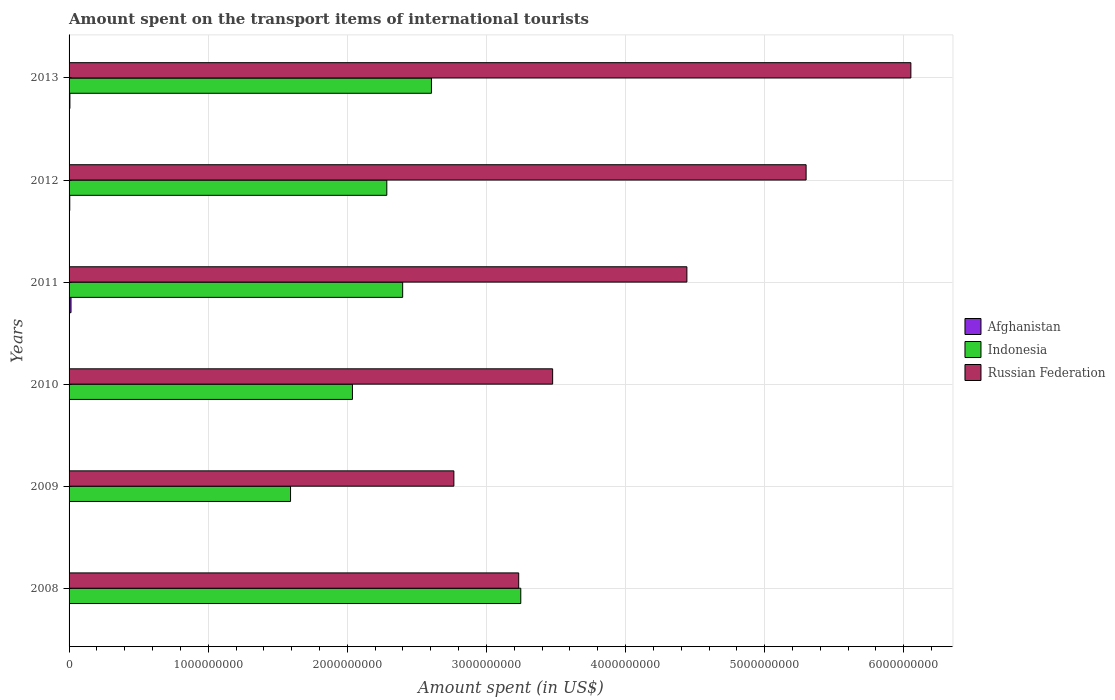How many different coloured bars are there?
Ensure brevity in your answer.  3. Are the number of bars per tick equal to the number of legend labels?
Give a very brief answer. Yes. Are the number of bars on each tick of the Y-axis equal?
Ensure brevity in your answer.  Yes. What is the label of the 6th group of bars from the top?
Your answer should be very brief. 2008. What is the amount spent on the transport items of international tourists in Russian Federation in 2013?
Provide a short and direct response. 6.05e+09. Across all years, what is the maximum amount spent on the transport items of international tourists in Russian Federation?
Provide a short and direct response. 6.05e+09. Across all years, what is the minimum amount spent on the transport items of international tourists in Indonesia?
Provide a succinct answer. 1.59e+09. In which year was the amount spent on the transport items of international tourists in Afghanistan minimum?
Make the answer very short. 2009. What is the total amount spent on the transport items of international tourists in Afghanistan in the graph?
Your response must be concise. 3.30e+07. What is the difference between the amount spent on the transport items of international tourists in Afghanistan in 2011 and that in 2013?
Your answer should be compact. 8.00e+06. What is the difference between the amount spent on the transport items of international tourists in Indonesia in 2010 and the amount spent on the transport items of international tourists in Russian Federation in 2011?
Offer a very short reply. -2.40e+09. What is the average amount spent on the transport items of international tourists in Afghanistan per year?
Give a very brief answer. 5.50e+06. In the year 2008, what is the difference between the amount spent on the transport items of international tourists in Indonesia and amount spent on the transport items of international tourists in Russian Federation?
Your answer should be very brief. 1.50e+07. In how many years, is the amount spent on the transport items of international tourists in Indonesia greater than 4600000000 US$?
Your response must be concise. 0. What is the ratio of the amount spent on the transport items of international tourists in Russian Federation in 2009 to that in 2013?
Your answer should be compact. 0.46. Is the amount spent on the transport items of international tourists in Afghanistan in 2009 less than that in 2010?
Provide a short and direct response. Yes. What is the difference between the highest and the second highest amount spent on the transport items of international tourists in Indonesia?
Make the answer very short. 6.42e+08. What is the difference between the highest and the lowest amount spent on the transport items of international tourists in Russian Federation?
Your answer should be very brief. 3.28e+09. Is the sum of the amount spent on the transport items of international tourists in Afghanistan in 2008 and 2011 greater than the maximum amount spent on the transport items of international tourists in Indonesia across all years?
Provide a short and direct response. No. Is it the case that in every year, the sum of the amount spent on the transport items of international tourists in Russian Federation and amount spent on the transport items of international tourists in Indonesia is greater than the amount spent on the transport items of international tourists in Afghanistan?
Make the answer very short. Yes. How many bars are there?
Ensure brevity in your answer.  18. Are all the bars in the graph horizontal?
Make the answer very short. Yes. Are the values on the major ticks of X-axis written in scientific E-notation?
Make the answer very short. No. Does the graph contain any zero values?
Offer a very short reply. No. How are the legend labels stacked?
Offer a terse response. Vertical. What is the title of the graph?
Provide a short and direct response. Amount spent on the transport items of international tourists. Does "Namibia" appear as one of the legend labels in the graph?
Offer a terse response. No. What is the label or title of the X-axis?
Offer a terse response. Amount spent (in US$). What is the label or title of the Y-axis?
Provide a succinct answer. Years. What is the Amount spent (in US$) of Afghanistan in 2008?
Keep it short and to the point. 3.00e+06. What is the Amount spent (in US$) of Indonesia in 2008?
Keep it short and to the point. 3.25e+09. What is the Amount spent (in US$) of Russian Federation in 2008?
Provide a short and direct response. 3.23e+09. What is the Amount spent (in US$) in Indonesia in 2009?
Provide a short and direct response. 1.59e+09. What is the Amount spent (in US$) in Russian Federation in 2009?
Your answer should be very brief. 2.77e+09. What is the Amount spent (in US$) in Afghanistan in 2010?
Your answer should be very brief. 3.00e+06. What is the Amount spent (in US$) in Indonesia in 2010?
Your response must be concise. 2.04e+09. What is the Amount spent (in US$) in Russian Federation in 2010?
Ensure brevity in your answer.  3.48e+09. What is the Amount spent (in US$) in Afghanistan in 2011?
Your answer should be very brief. 1.40e+07. What is the Amount spent (in US$) in Indonesia in 2011?
Keep it short and to the point. 2.40e+09. What is the Amount spent (in US$) in Russian Federation in 2011?
Offer a terse response. 4.44e+09. What is the Amount spent (in US$) of Indonesia in 2012?
Give a very brief answer. 2.28e+09. What is the Amount spent (in US$) in Russian Federation in 2012?
Ensure brevity in your answer.  5.30e+09. What is the Amount spent (in US$) in Indonesia in 2013?
Provide a succinct answer. 2.60e+09. What is the Amount spent (in US$) of Russian Federation in 2013?
Give a very brief answer. 6.05e+09. Across all years, what is the maximum Amount spent (in US$) in Afghanistan?
Make the answer very short. 1.40e+07. Across all years, what is the maximum Amount spent (in US$) in Indonesia?
Offer a terse response. 3.25e+09. Across all years, what is the maximum Amount spent (in US$) in Russian Federation?
Offer a very short reply. 6.05e+09. Across all years, what is the minimum Amount spent (in US$) in Indonesia?
Your response must be concise. 1.59e+09. Across all years, what is the minimum Amount spent (in US$) of Russian Federation?
Ensure brevity in your answer.  2.77e+09. What is the total Amount spent (in US$) of Afghanistan in the graph?
Ensure brevity in your answer.  3.30e+07. What is the total Amount spent (in US$) in Indonesia in the graph?
Provide a succinct answer. 1.42e+1. What is the total Amount spent (in US$) in Russian Federation in the graph?
Ensure brevity in your answer.  2.53e+1. What is the difference between the Amount spent (in US$) of Indonesia in 2008 and that in 2009?
Provide a succinct answer. 1.66e+09. What is the difference between the Amount spent (in US$) of Russian Federation in 2008 and that in 2009?
Keep it short and to the point. 4.66e+08. What is the difference between the Amount spent (in US$) of Indonesia in 2008 and that in 2010?
Your answer should be very brief. 1.21e+09. What is the difference between the Amount spent (in US$) in Russian Federation in 2008 and that in 2010?
Offer a terse response. -2.44e+08. What is the difference between the Amount spent (in US$) of Afghanistan in 2008 and that in 2011?
Provide a succinct answer. -1.10e+07. What is the difference between the Amount spent (in US$) in Indonesia in 2008 and that in 2011?
Offer a very short reply. 8.49e+08. What is the difference between the Amount spent (in US$) of Russian Federation in 2008 and that in 2011?
Provide a short and direct response. -1.21e+09. What is the difference between the Amount spent (in US$) in Indonesia in 2008 and that in 2012?
Offer a terse response. 9.63e+08. What is the difference between the Amount spent (in US$) in Russian Federation in 2008 and that in 2012?
Your answer should be compact. -2.07e+09. What is the difference between the Amount spent (in US$) of Indonesia in 2008 and that in 2013?
Provide a succinct answer. 6.42e+08. What is the difference between the Amount spent (in US$) of Russian Federation in 2008 and that in 2013?
Your response must be concise. -2.82e+09. What is the difference between the Amount spent (in US$) of Indonesia in 2009 and that in 2010?
Make the answer very short. -4.45e+08. What is the difference between the Amount spent (in US$) in Russian Federation in 2009 and that in 2010?
Your answer should be very brief. -7.10e+08. What is the difference between the Amount spent (in US$) of Afghanistan in 2009 and that in 2011?
Give a very brief answer. -1.20e+07. What is the difference between the Amount spent (in US$) of Indonesia in 2009 and that in 2011?
Provide a short and direct response. -8.06e+08. What is the difference between the Amount spent (in US$) in Russian Federation in 2009 and that in 2011?
Provide a succinct answer. -1.68e+09. What is the difference between the Amount spent (in US$) of Indonesia in 2009 and that in 2012?
Your answer should be compact. -6.92e+08. What is the difference between the Amount spent (in US$) of Russian Federation in 2009 and that in 2012?
Ensure brevity in your answer.  -2.53e+09. What is the difference between the Amount spent (in US$) in Afghanistan in 2009 and that in 2013?
Your answer should be very brief. -4.00e+06. What is the difference between the Amount spent (in US$) in Indonesia in 2009 and that in 2013?
Your answer should be very brief. -1.01e+09. What is the difference between the Amount spent (in US$) of Russian Federation in 2009 and that in 2013?
Ensure brevity in your answer.  -3.28e+09. What is the difference between the Amount spent (in US$) in Afghanistan in 2010 and that in 2011?
Keep it short and to the point. -1.10e+07. What is the difference between the Amount spent (in US$) in Indonesia in 2010 and that in 2011?
Provide a succinct answer. -3.61e+08. What is the difference between the Amount spent (in US$) of Russian Federation in 2010 and that in 2011?
Your response must be concise. -9.65e+08. What is the difference between the Amount spent (in US$) of Afghanistan in 2010 and that in 2012?
Provide a succinct answer. -2.00e+06. What is the difference between the Amount spent (in US$) in Indonesia in 2010 and that in 2012?
Keep it short and to the point. -2.47e+08. What is the difference between the Amount spent (in US$) in Russian Federation in 2010 and that in 2012?
Give a very brief answer. -1.82e+09. What is the difference between the Amount spent (in US$) of Afghanistan in 2010 and that in 2013?
Make the answer very short. -3.00e+06. What is the difference between the Amount spent (in US$) in Indonesia in 2010 and that in 2013?
Offer a terse response. -5.68e+08. What is the difference between the Amount spent (in US$) of Russian Federation in 2010 and that in 2013?
Make the answer very short. -2.58e+09. What is the difference between the Amount spent (in US$) in Afghanistan in 2011 and that in 2012?
Keep it short and to the point. 9.00e+06. What is the difference between the Amount spent (in US$) of Indonesia in 2011 and that in 2012?
Give a very brief answer. 1.14e+08. What is the difference between the Amount spent (in US$) in Russian Federation in 2011 and that in 2012?
Provide a short and direct response. -8.57e+08. What is the difference between the Amount spent (in US$) of Indonesia in 2011 and that in 2013?
Provide a succinct answer. -2.07e+08. What is the difference between the Amount spent (in US$) in Russian Federation in 2011 and that in 2013?
Provide a succinct answer. -1.61e+09. What is the difference between the Amount spent (in US$) of Indonesia in 2012 and that in 2013?
Give a very brief answer. -3.21e+08. What is the difference between the Amount spent (in US$) in Russian Federation in 2012 and that in 2013?
Provide a succinct answer. -7.53e+08. What is the difference between the Amount spent (in US$) of Afghanistan in 2008 and the Amount spent (in US$) of Indonesia in 2009?
Your response must be concise. -1.59e+09. What is the difference between the Amount spent (in US$) of Afghanistan in 2008 and the Amount spent (in US$) of Russian Federation in 2009?
Provide a short and direct response. -2.76e+09. What is the difference between the Amount spent (in US$) in Indonesia in 2008 and the Amount spent (in US$) in Russian Federation in 2009?
Offer a very short reply. 4.81e+08. What is the difference between the Amount spent (in US$) in Afghanistan in 2008 and the Amount spent (in US$) in Indonesia in 2010?
Make the answer very short. -2.03e+09. What is the difference between the Amount spent (in US$) of Afghanistan in 2008 and the Amount spent (in US$) of Russian Federation in 2010?
Keep it short and to the point. -3.47e+09. What is the difference between the Amount spent (in US$) in Indonesia in 2008 and the Amount spent (in US$) in Russian Federation in 2010?
Provide a succinct answer. -2.29e+08. What is the difference between the Amount spent (in US$) in Afghanistan in 2008 and the Amount spent (in US$) in Indonesia in 2011?
Offer a very short reply. -2.40e+09. What is the difference between the Amount spent (in US$) of Afghanistan in 2008 and the Amount spent (in US$) of Russian Federation in 2011?
Provide a short and direct response. -4.44e+09. What is the difference between the Amount spent (in US$) in Indonesia in 2008 and the Amount spent (in US$) in Russian Federation in 2011?
Make the answer very short. -1.19e+09. What is the difference between the Amount spent (in US$) in Afghanistan in 2008 and the Amount spent (in US$) in Indonesia in 2012?
Provide a short and direct response. -2.28e+09. What is the difference between the Amount spent (in US$) of Afghanistan in 2008 and the Amount spent (in US$) of Russian Federation in 2012?
Give a very brief answer. -5.30e+09. What is the difference between the Amount spent (in US$) of Indonesia in 2008 and the Amount spent (in US$) of Russian Federation in 2012?
Give a very brief answer. -2.05e+09. What is the difference between the Amount spent (in US$) in Afghanistan in 2008 and the Amount spent (in US$) in Indonesia in 2013?
Your answer should be very brief. -2.60e+09. What is the difference between the Amount spent (in US$) of Afghanistan in 2008 and the Amount spent (in US$) of Russian Federation in 2013?
Ensure brevity in your answer.  -6.05e+09. What is the difference between the Amount spent (in US$) of Indonesia in 2008 and the Amount spent (in US$) of Russian Federation in 2013?
Keep it short and to the point. -2.80e+09. What is the difference between the Amount spent (in US$) of Afghanistan in 2009 and the Amount spent (in US$) of Indonesia in 2010?
Offer a very short reply. -2.04e+09. What is the difference between the Amount spent (in US$) in Afghanistan in 2009 and the Amount spent (in US$) in Russian Federation in 2010?
Provide a short and direct response. -3.47e+09. What is the difference between the Amount spent (in US$) of Indonesia in 2009 and the Amount spent (in US$) of Russian Federation in 2010?
Make the answer very short. -1.88e+09. What is the difference between the Amount spent (in US$) of Afghanistan in 2009 and the Amount spent (in US$) of Indonesia in 2011?
Your answer should be very brief. -2.40e+09. What is the difference between the Amount spent (in US$) in Afghanistan in 2009 and the Amount spent (in US$) in Russian Federation in 2011?
Your answer should be very brief. -4.44e+09. What is the difference between the Amount spent (in US$) of Indonesia in 2009 and the Amount spent (in US$) of Russian Federation in 2011?
Give a very brief answer. -2.85e+09. What is the difference between the Amount spent (in US$) in Afghanistan in 2009 and the Amount spent (in US$) in Indonesia in 2012?
Make the answer very short. -2.28e+09. What is the difference between the Amount spent (in US$) in Afghanistan in 2009 and the Amount spent (in US$) in Russian Federation in 2012?
Keep it short and to the point. -5.30e+09. What is the difference between the Amount spent (in US$) in Indonesia in 2009 and the Amount spent (in US$) in Russian Federation in 2012?
Keep it short and to the point. -3.71e+09. What is the difference between the Amount spent (in US$) of Afghanistan in 2009 and the Amount spent (in US$) of Indonesia in 2013?
Keep it short and to the point. -2.60e+09. What is the difference between the Amount spent (in US$) of Afghanistan in 2009 and the Amount spent (in US$) of Russian Federation in 2013?
Give a very brief answer. -6.05e+09. What is the difference between the Amount spent (in US$) of Indonesia in 2009 and the Amount spent (in US$) of Russian Federation in 2013?
Offer a terse response. -4.46e+09. What is the difference between the Amount spent (in US$) of Afghanistan in 2010 and the Amount spent (in US$) of Indonesia in 2011?
Provide a succinct answer. -2.40e+09. What is the difference between the Amount spent (in US$) in Afghanistan in 2010 and the Amount spent (in US$) in Russian Federation in 2011?
Your answer should be very brief. -4.44e+09. What is the difference between the Amount spent (in US$) of Indonesia in 2010 and the Amount spent (in US$) of Russian Federation in 2011?
Your answer should be compact. -2.40e+09. What is the difference between the Amount spent (in US$) in Afghanistan in 2010 and the Amount spent (in US$) in Indonesia in 2012?
Provide a succinct answer. -2.28e+09. What is the difference between the Amount spent (in US$) of Afghanistan in 2010 and the Amount spent (in US$) of Russian Federation in 2012?
Give a very brief answer. -5.30e+09. What is the difference between the Amount spent (in US$) in Indonesia in 2010 and the Amount spent (in US$) in Russian Federation in 2012?
Offer a terse response. -3.26e+09. What is the difference between the Amount spent (in US$) in Afghanistan in 2010 and the Amount spent (in US$) in Indonesia in 2013?
Provide a short and direct response. -2.60e+09. What is the difference between the Amount spent (in US$) of Afghanistan in 2010 and the Amount spent (in US$) of Russian Federation in 2013?
Provide a succinct answer. -6.05e+09. What is the difference between the Amount spent (in US$) of Indonesia in 2010 and the Amount spent (in US$) of Russian Federation in 2013?
Offer a terse response. -4.01e+09. What is the difference between the Amount spent (in US$) in Afghanistan in 2011 and the Amount spent (in US$) in Indonesia in 2012?
Provide a short and direct response. -2.27e+09. What is the difference between the Amount spent (in US$) of Afghanistan in 2011 and the Amount spent (in US$) of Russian Federation in 2012?
Your answer should be very brief. -5.28e+09. What is the difference between the Amount spent (in US$) of Indonesia in 2011 and the Amount spent (in US$) of Russian Federation in 2012?
Provide a short and direct response. -2.90e+09. What is the difference between the Amount spent (in US$) in Afghanistan in 2011 and the Amount spent (in US$) in Indonesia in 2013?
Give a very brief answer. -2.59e+09. What is the difference between the Amount spent (in US$) in Afghanistan in 2011 and the Amount spent (in US$) in Russian Federation in 2013?
Your answer should be compact. -6.04e+09. What is the difference between the Amount spent (in US$) of Indonesia in 2011 and the Amount spent (in US$) of Russian Federation in 2013?
Keep it short and to the point. -3.65e+09. What is the difference between the Amount spent (in US$) of Afghanistan in 2012 and the Amount spent (in US$) of Indonesia in 2013?
Give a very brief answer. -2.60e+09. What is the difference between the Amount spent (in US$) of Afghanistan in 2012 and the Amount spent (in US$) of Russian Federation in 2013?
Your answer should be compact. -6.05e+09. What is the difference between the Amount spent (in US$) in Indonesia in 2012 and the Amount spent (in US$) in Russian Federation in 2013?
Your response must be concise. -3.77e+09. What is the average Amount spent (in US$) in Afghanistan per year?
Your response must be concise. 5.50e+06. What is the average Amount spent (in US$) in Indonesia per year?
Keep it short and to the point. 2.36e+09. What is the average Amount spent (in US$) of Russian Federation per year?
Keep it short and to the point. 4.21e+09. In the year 2008, what is the difference between the Amount spent (in US$) in Afghanistan and Amount spent (in US$) in Indonesia?
Provide a succinct answer. -3.24e+09. In the year 2008, what is the difference between the Amount spent (in US$) in Afghanistan and Amount spent (in US$) in Russian Federation?
Offer a terse response. -3.23e+09. In the year 2008, what is the difference between the Amount spent (in US$) in Indonesia and Amount spent (in US$) in Russian Federation?
Your response must be concise. 1.50e+07. In the year 2009, what is the difference between the Amount spent (in US$) of Afghanistan and Amount spent (in US$) of Indonesia?
Make the answer very short. -1.59e+09. In the year 2009, what is the difference between the Amount spent (in US$) of Afghanistan and Amount spent (in US$) of Russian Federation?
Provide a succinct answer. -2.76e+09. In the year 2009, what is the difference between the Amount spent (in US$) in Indonesia and Amount spent (in US$) in Russian Federation?
Make the answer very short. -1.17e+09. In the year 2010, what is the difference between the Amount spent (in US$) in Afghanistan and Amount spent (in US$) in Indonesia?
Offer a terse response. -2.03e+09. In the year 2010, what is the difference between the Amount spent (in US$) of Afghanistan and Amount spent (in US$) of Russian Federation?
Make the answer very short. -3.47e+09. In the year 2010, what is the difference between the Amount spent (in US$) of Indonesia and Amount spent (in US$) of Russian Federation?
Provide a short and direct response. -1.44e+09. In the year 2011, what is the difference between the Amount spent (in US$) of Afghanistan and Amount spent (in US$) of Indonesia?
Provide a short and direct response. -2.38e+09. In the year 2011, what is the difference between the Amount spent (in US$) in Afghanistan and Amount spent (in US$) in Russian Federation?
Provide a succinct answer. -4.43e+09. In the year 2011, what is the difference between the Amount spent (in US$) in Indonesia and Amount spent (in US$) in Russian Federation?
Your answer should be compact. -2.04e+09. In the year 2012, what is the difference between the Amount spent (in US$) in Afghanistan and Amount spent (in US$) in Indonesia?
Provide a short and direct response. -2.28e+09. In the year 2012, what is the difference between the Amount spent (in US$) of Afghanistan and Amount spent (in US$) of Russian Federation?
Provide a short and direct response. -5.29e+09. In the year 2012, what is the difference between the Amount spent (in US$) in Indonesia and Amount spent (in US$) in Russian Federation?
Offer a terse response. -3.01e+09. In the year 2013, what is the difference between the Amount spent (in US$) of Afghanistan and Amount spent (in US$) of Indonesia?
Make the answer very short. -2.60e+09. In the year 2013, what is the difference between the Amount spent (in US$) in Afghanistan and Amount spent (in US$) in Russian Federation?
Ensure brevity in your answer.  -6.04e+09. In the year 2013, what is the difference between the Amount spent (in US$) in Indonesia and Amount spent (in US$) in Russian Federation?
Your answer should be compact. -3.45e+09. What is the ratio of the Amount spent (in US$) of Indonesia in 2008 to that in 2009?
Keep it short and to the point. 2.04. What is the ratio of the Amount spent (in US$) in Russian Federation in 2008 to that in 2009?
Your response must be concise. 1.17. What is the ratio of the Amount spent (in US$) of Indonesia in 2008 to that in 2010?
Offer a very short reply. 1.59. What is the ratio of the Amount spent (in US$) in Russian Federation in 2008 to that in 2010?
Ensure brevity in your answer.  0.93. What is the ratio of the Amount spent (in US$) of Afghanistan in 2008 to that in 2011?
Your answer should be compact. 0.21. What is the ratio of the Amount spent (in US$) in Indonesia in 2008 to that in 2011?
Your answer should be very brief. 1.35. What is the ratio of the Amount spent (in US$) of Russian Federation in 2008 to that in 2011?
Keep it short and to the point. 0.73. What is the ratio of the Amount spent (in US$) of Afghanistan in 2008 to that in 2012?
Keep it short and to the point. 0.6. What is the ratio of the Amount spent (in US$) of Indonesia in 2008 to that in 2012?
Your answer should be very brief. 1.42. What is the ratio of the Amount spent (in US$) of Russian Federation in 2008 to that in 2012?
Give a very brief answer. 0.61. What is the ratio of the Amount spent (in US$) in Afghanistan in 2008 to that in 2013?
Give a very brief answer. 0.5. What is the ratio of the Amount spent (in US$) of Indonesia in 2008 to that in 2013?
Offer a very short reply. 1.25. What is the ratio of the Amount spent (in US$) of Russian Federation in 2008 to that in 2013?
Offer a terse response. 0.53. What is the ratio of the Amount spent (in US$) in Afghanistan in 2009 to that in 2010?
Your answer should be very brief. 0.67. What is the ratio of the Amount spent (in US$) of Indonesia in 2009 to that in 2010?
Ensure brevity in your answer.  0.78. What is the ratio of the Amount spent (in US$) of Russian Federation in 2009 to that in 2010?
Your answer should be compact. 0.8. What is the ratio of the Amount spent (in US$) of Afghanistan in 2009 to that in 2011?
Make the answer very short. 0.14. What is the ratio of the Amount spent (in US$) in Indonesia in 2009 to that in 2011?
Provide a succinct answer. 0.66. What is the ratio of the Amount spent (in US$) of Russian Federation in 2009 to that in 2011?
Your answer should be very brief. 0.62. What is the ratio of the Amount spent (in US$) in Indonesia in 2009 to that in 2012?
Provide a short and direct response. 0.7. What is the ratio of the Amount spent (in US$) of Russian Federation in 2009 to that in 2012?
Keep it short and to the point. 0.52. What is the ratio of the Amount spent (in US$) in Indonesia in 2009 to that in 2013?
Make the answer very short. 0.61. What is the ratio of the Amount spent (in US$) in Russian Federation in 2009 to that in 2013?
Offer a very short reply. 0.46. What is the ratio of the Amount spent (in US$) of Afghanistan in 2010 to that in 2011?
Make the answer very short. 0.21. What is the ratio of the Amount spent (in US$) in Indonesia in 2010 to that in 2011?
Offer a terse response. 0.85. What is the ratio of the Amount spent (in US$) in Russian Federation in 2010 to that in 2011?
Provide a succinct answer. 0.78. What is the ratio of the Amount spent (in US$) of Afghanistan in 2010 to that in 2012?
Give a very brief answer. 0.6. What is the ratio of the Amount spent (in US$) of Indonesia in 2010 to that in 2012?
Keep it short and to the point. 0.89. What is the ratio of the Amount spent (in US$) of Russian Federation in 2010 to that in 2012?
Your answer should be compact. 0.66. What is the ratio of the Amount spent (in US$) of Afghanistan in 2010 to that in 2013?
Keep it short and to the point. 0.5. What is the ratio of the Amount spent (in US$) of Indonesia in 2010 to that in 2013?
Provide a succinct answer. 0.78. What is the ratio of the Amount spent (in US$) of Russian Federation in 2010 to that in 2013?
Your answer should be very brief. 0.57. What is the ratio of the Amount spent (in US$) of Indonesia in 2011 to that in 2012?
Ensure brevity in your answer.  1.05. What is the ratio of the Amount spent (in US$) in Russian Federation in 2011 to that in 2012?
Your answer should be very brief. 0.84. What is the ratio of the Amount spent (in US$) of Afghanistan in 2011 to that in 2013?
Make the answer very short. 2.33. What is the ratio of the Amount spent (in US$) of Indonesia in 2011 to that in 2013?
Make the answer very short. 0.92. What is the ratio of the Amount spent (in US$) of Russian Federation in 2011 to that in 2013?
Keep it short and to the point. 0.73. What is the ratio of the Amount spent (in US$) of Indonesia in 2012 to that in 2013?
Your answer should be compact. 0.88. What is the ratio of the Amount spent (in US$) of Russian Federation in 2012 to that in 2013?
Ensure brevity in your answer.  0.88. What is the difference between the highest and the second highest Amount spent (in US$) of Indonesia?
Keep it short and to the point. 6.42e+08. What is the difference between the highest and the second highest Amount spent (in US$) of Russian Federation?
Your answer should be compact. 7.53e+08. What is the difference between the highest and the lowest Amount spent (in US$) of Afghanistan?
Provide a succinct answer. 1.20e+07. What is the difference between the highest and the lowest Amount spent (in US$) of Indonesia?
Give a very brief answer. 1.66e+09. What is the difference between the highest and the lowest Amount spent (in US$) of Russian Federation?
Keep it short and to the point. 3.28e+09. 